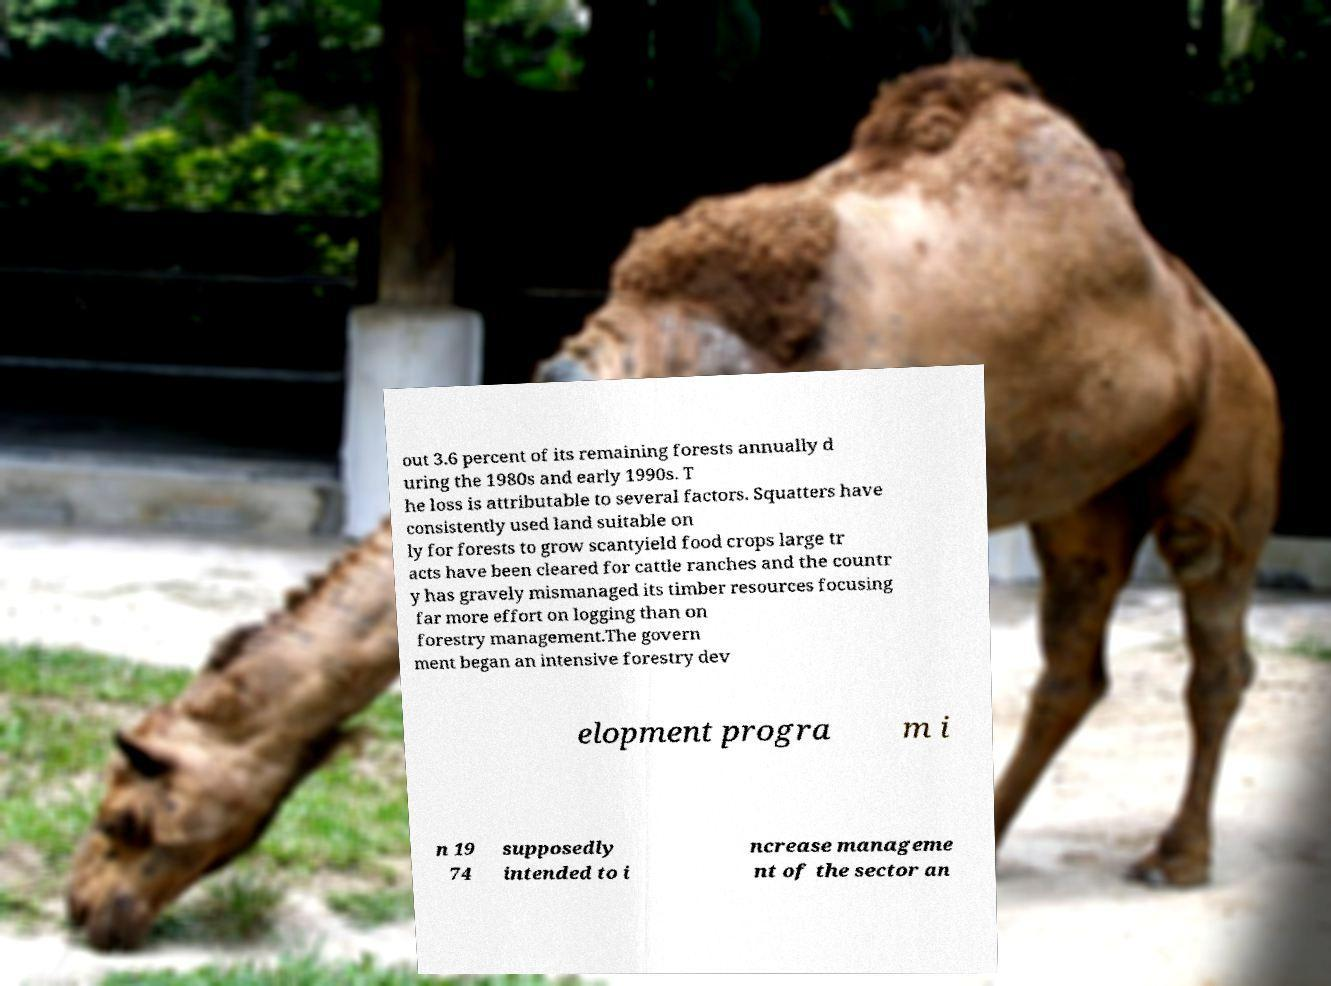Could you assist in decoding the text presented in this image and type it out clearly? out 3.6 percent of its remaining forests annually d uring the 1980s and early 1990s. T he loss is attributable to several factors. Squatters have consistently used land suitable on ly for forests to grow scantyield food crops large tr acts have been cleared for cattle ranches and the countr y has gravely mismanaged its timber resources focusing far more effort on logging than on forestry management.The govern ment began an intensive forestry dev elopment progra m i n 19 74 supposedly intended to i ncrease manageme nt of the sector an 